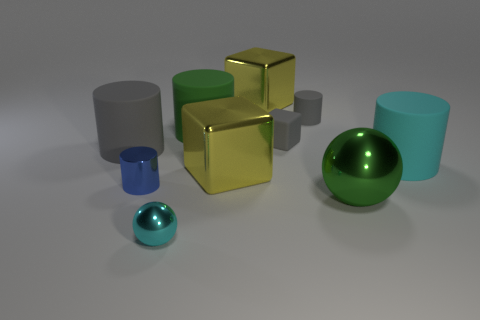Do the matte cube and the tiny rubber cylinder have the same color?
Make the answer very short. Yes. Is the shape of the big yellow object behind the large gray cylinder the same as the rubber thing that is on the left side of the cyan metallic sphere?
Your answer should be compact. No. Does the cylinder that is behind the green rubber cylinder have the same color as the cylinder left of the shiny cylinder?
Provide a succinct answer. Yes. There is a thing to the left of the blue shiny cylinder; does it have the same size as the tiny cyan metallic sphere?
Your response must be concise. No. What shape is the thing that is in front of the blue cylinder and behind the small cyan thing?
Offer a very short reply. Sphere. There is a tiny cyan object; are there any yellow metallic blocks behind it?
Your response must be concise. Yes. Is the shape of the big gray rubber thing the same as the small blue object?
Your response must be concise. Yes. Are there the same number of blue metallic things that are to the right of the big green rubber cylinder and large cyan matte things that are behind the cyan cylinder?
Your response must be concise. Yes. What number of other things are there of the same material as the small blue thing
Keep it short and to the point. 4. What number of big objects are either green metal objects or green matte cylinders?
Your answer should be very brief. 2. 